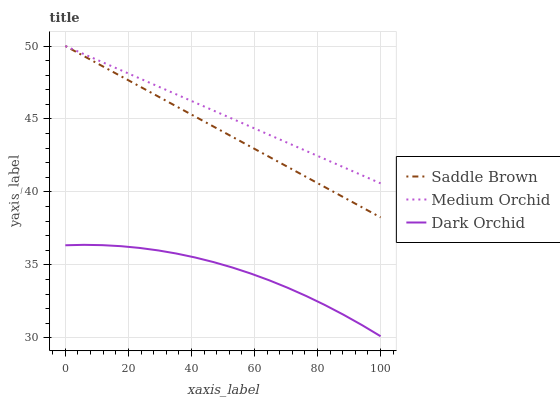Does Saddle Brown have the minimum area under the curve?
Answer yes or no. No. Does Saddle Brown have the maximum area under the curve?
Answer yes or no. No. Is Saddle Brown the smoothest?
Answer yes or no. No. Is Saddle Brown the roughest?
Answer yes or no. No. Does Saddle Brown have the lowest value?
Answer yes or no. No. Does Dark Orchid have the highest value?
Answer yes or no. No. Is Dark Orchid less than Medium Orchid?
Answer yes or no. Yes. Is Saddle Brown greater than Dark Orchid?
Answer yes or no. Yes. Does Dark Orchid intersect Medium Orchid?
Answer yes or no. No. 